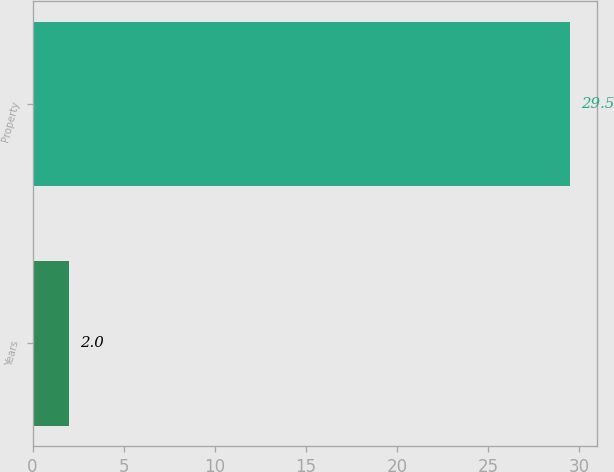<chart> <loc_0><loc_0><loc_500><loc_500><bar_chart><fcel>Years<fcel>Property<nl><fcel>2<fcel>29.5<nl></chart> 